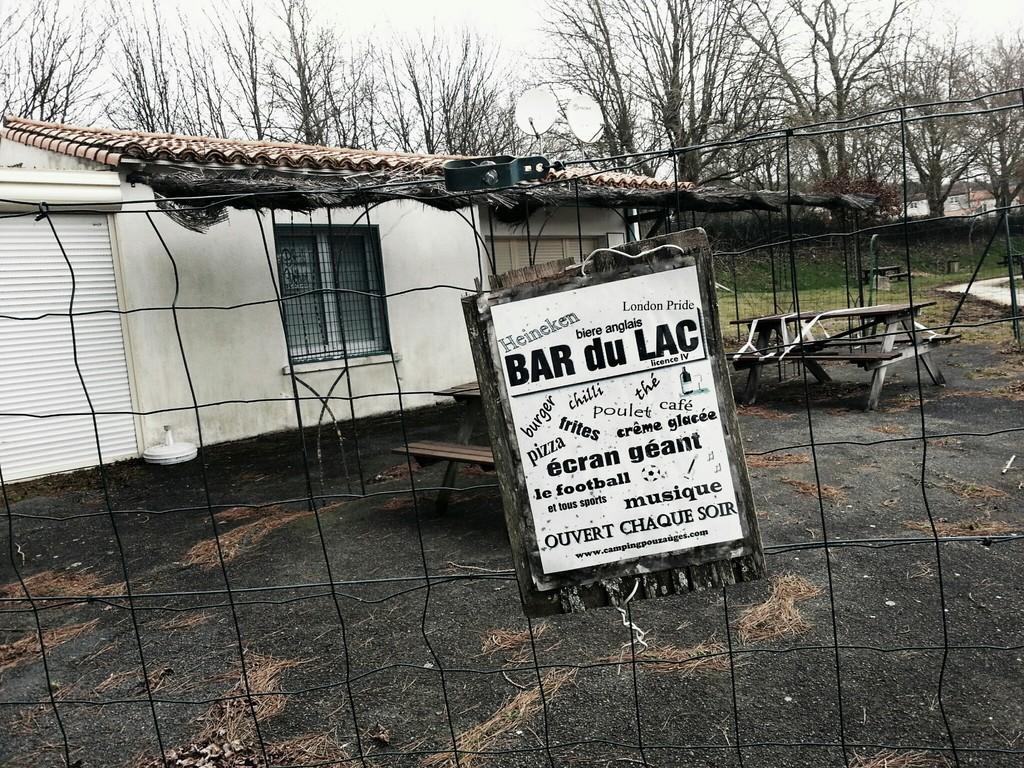What sport is listed on this sign?
Provide a short and direct response. Football. What language is the sign in?
Your response must be concise. Unanswerable. 